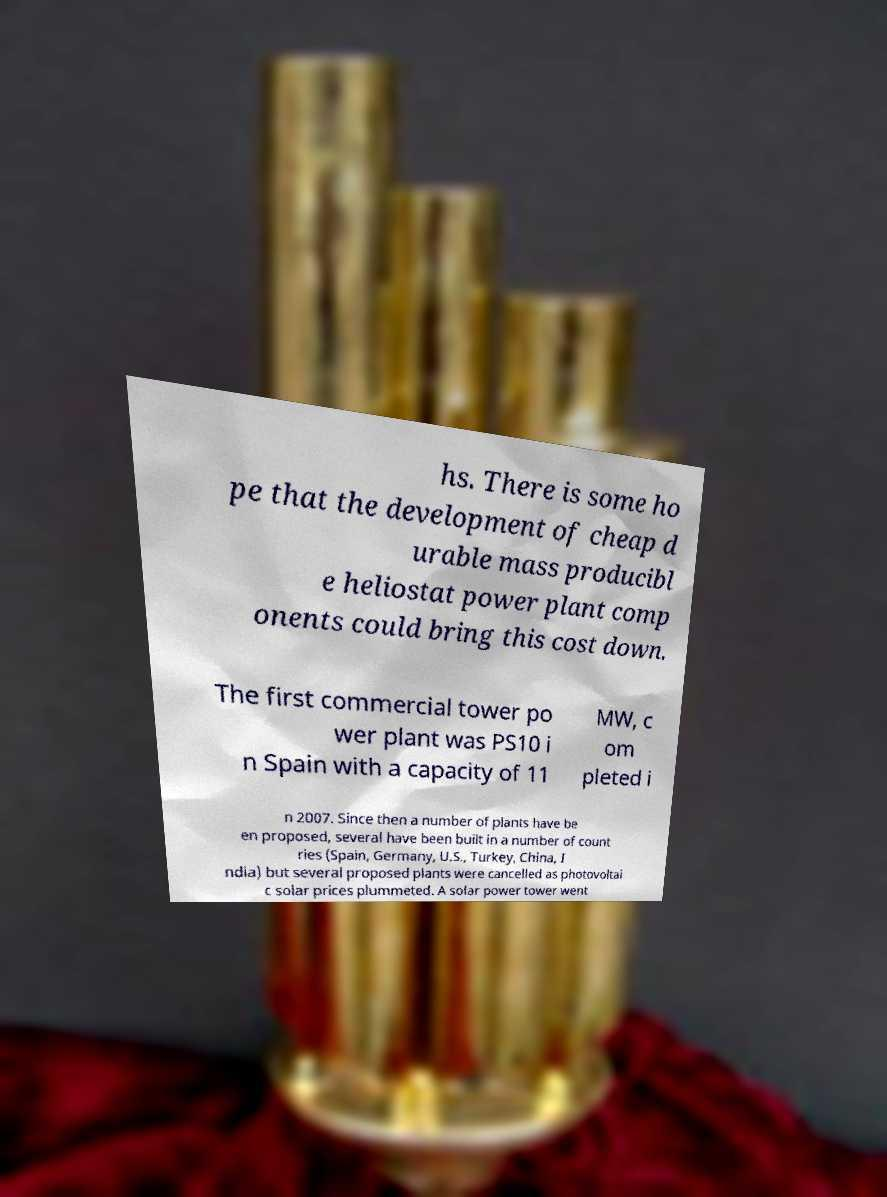Please read and relay the text visible in this image. What does it say? hs. There is some ho pe that the development of cheap d urable mass producibl e heliostat power plant comp onents could bring this cost down. The first commercial tower po wer plant was PS10 i n Spain with a capacity of 11 MW, c om pleted i n 2007. Since then a number of plants have be en proposed, several have been built in a number of count ries (Spain, Germany, U.S., Turkey, China, I ndia) but several proposed plants were cancelled as photovoltai c solar prices plummeted. A solar power tower went 